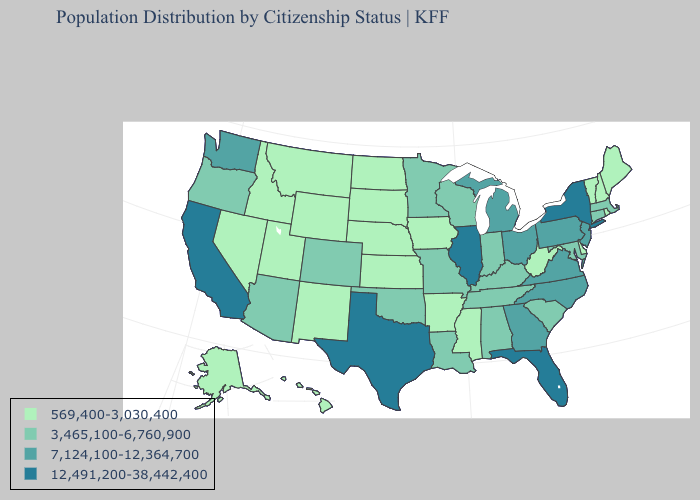Is the legend a continuous bar?
Answer briefly. No. What is the lowest value in the USA?
Keep it brief. 569,400-3,030,400. What is the highest value in states that border Oklahoma?
Concise answer only. 12,491,200-38,442,400. What is the value of Colorado?
Concise answer only. 3,465,100-6,760,900. What is the value of Florida?
Write a very short answer. 12,491,200-38,442,400. What is the lowest value in states that border Georgia?
Give a very brief answer. 3,465,100-6,760,900. Name the states that have a value in the range 7,124,100-12,364,700?
Concise answer only. Georgia, Michigan, New Jersey, North Carolina, Ohio, Pennsylvania, Virginia, Washington. How many symbols are there in the legend?
Be succinct. 4. What is the value of New Jersey?
Answer briefly. 7,124,100-12,364,700. Does Maine have the lowest value in the Northeast?
Be succinct. Yes. Which states have the lowest value in the USA?
Write a very short answer. Alaska, Arkansas, Delaware, Hawaii, Idaho, Iowa, Kansas, Maine, Mississippi, Montana, Nebraska, Nevada, New Hampshire, New Mexico, North Dakota, Rhode Island, South Dakota, Utah, Vermont, West Virginia, Wyoming. Name the states that have a value in the range 12,491,200-38,442,400?
Write a very short answer. California, Florida, Illinois, New York, Texas. What is the highest value in the MidWest ?
Answer briefly. 12,491,200-38,442,400. What is the highest value in the USA?
Give a very brief answer. 12,491,200-38,442,400. Does South Carolina have a higher value than New Hampshire?
Concise answer only. Yes. 